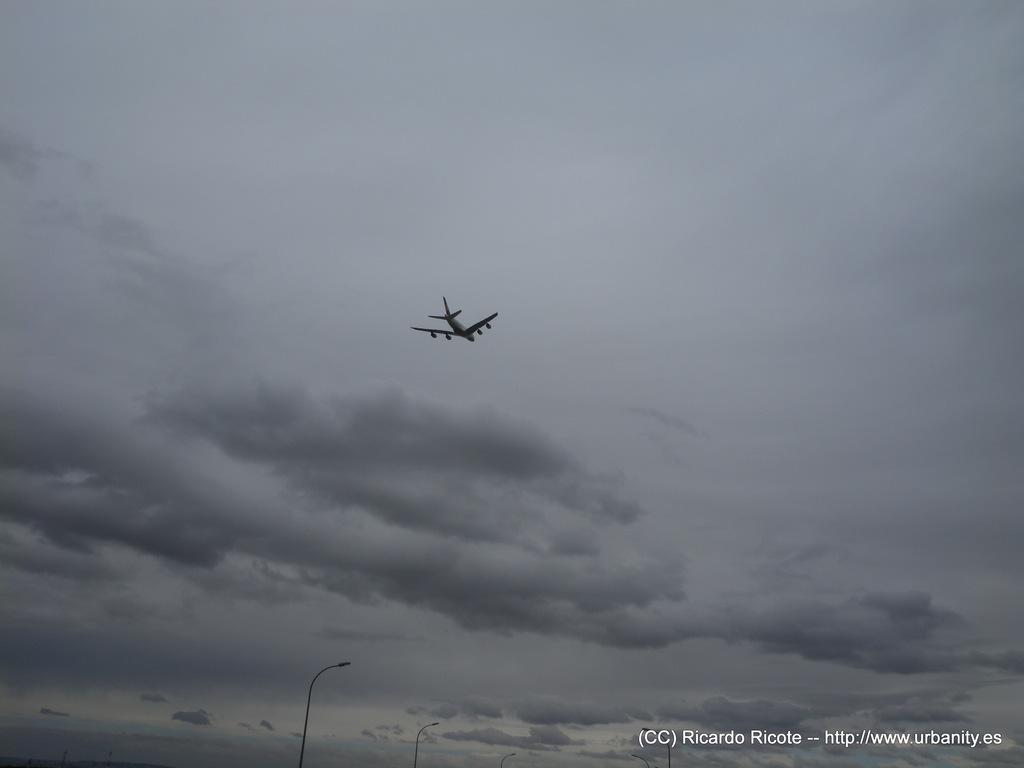In one or two sentences, can you explain what this image depicts? In this image I can see an aircraft, background I can see few light poles and the sky is in white and gray color. 